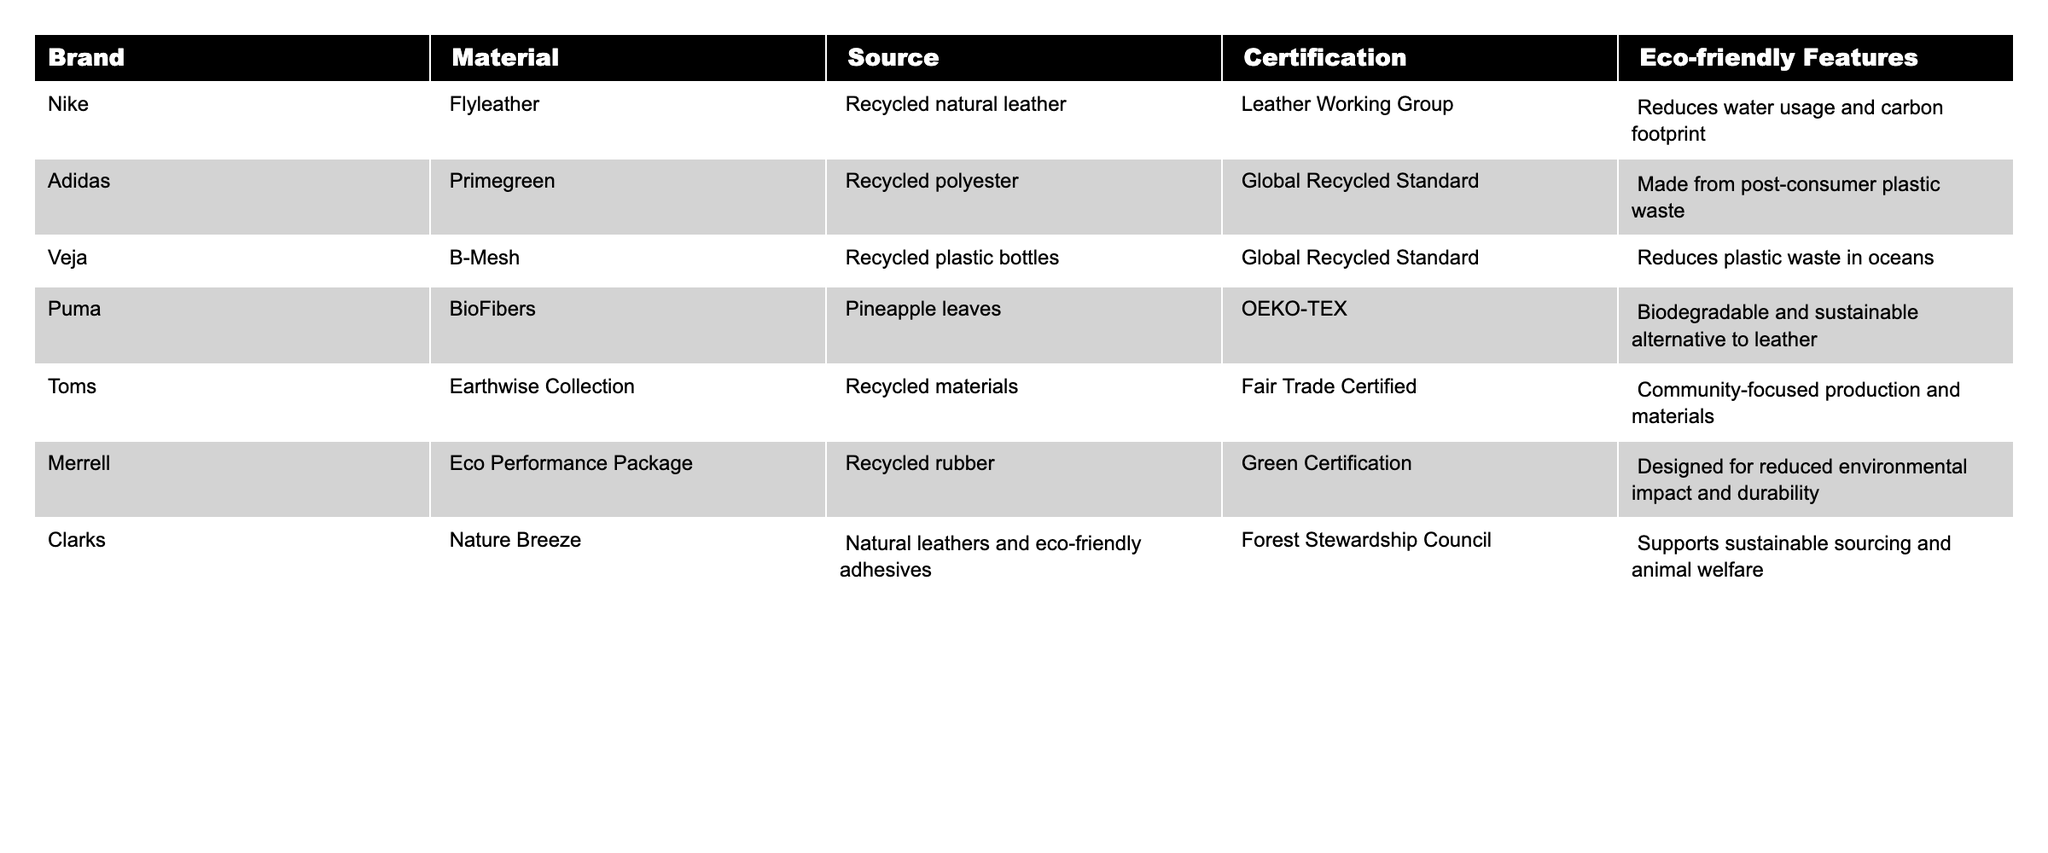What material does Veja use for its footwear? According to the table, Veja uses B-Mesh which is made from recycled plastic bottles.
Answer: Recycled plastic bottles Which footwear brand uses natural leathers and eco-friendly adhesives? From the table, Clarks is the brand that uses natural leathers and eco-friendly adhesives in their Nature Breeze line.
Answer: Clarks How many brands have certifications related to sustainability? The table lists certifications for six brands: Nike, Adidas, Veja, Puma, Toms, and Clarks. So, there are six brands with certifications.
Answer: Six brands Is Puma's BioFibers material biodegradable? The table indicates that Puma categorizes its BioFibers as a biodegradable and sustainable alternative to leather, confirming it is biodegradable.
Answer: Yes Do any brands use recycled materials? If so, which ones? The table shows that Nike, Adidas, Veja, Toms, and Merrell use recycled materials in their products.
Answer: Yes, Nike, Adidas, Veja, Toms, and Merrell Which brand has the most eco-friendly features listed? Reviewing the eco-friendly features, all brands seem to highlight significant benefits, but there's no indication of a ranking in the table. Thus, it's subjective and depends on the interpretation of what constitutes "most eco-friendly."
Answer: It varies What is the main source of material for Adidas's footwear? For Adidas, the main source of material is recycled polyester, which is specified in the table.
Answer: Recycled polyester Which brand's eco-friendly features focus on community production? The table identifies Toms as having eco-friendly features that focus on community-focused production and materials.
Answer: Toms How many brands obtained certification from the Global Recycled Standard? Both Adidas and Veja are certified under the Global Recycled Standard, totaling two brands.
Answer: Two brands Which material is the only biodegradable option listed? Puma's BioFibers is identified in the table as the only biodegradable option among the materials listed.
Answer: BioFibers 